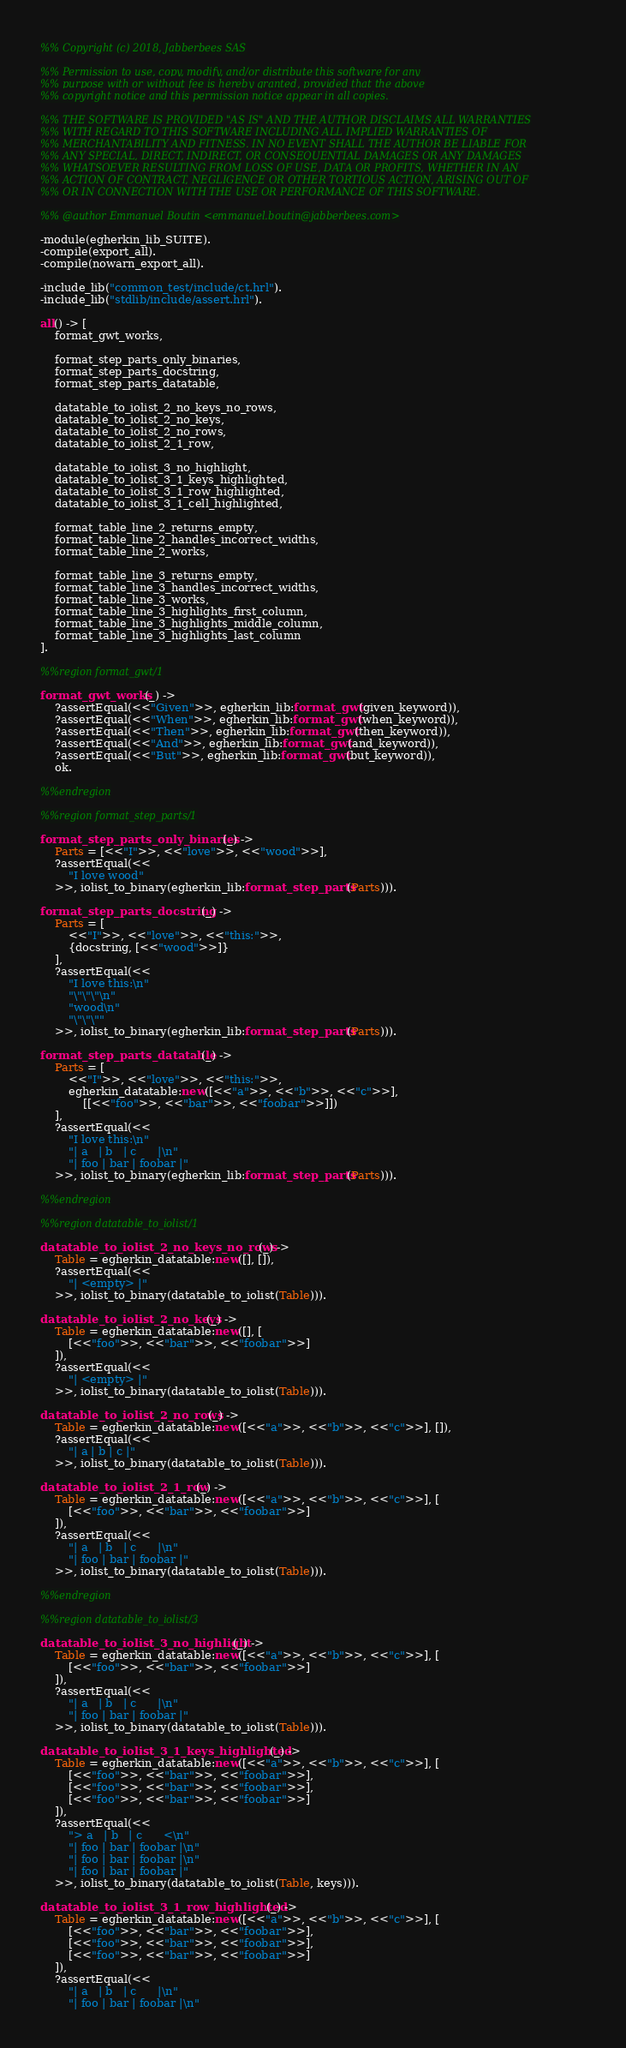Convert code to text. <code><loc_0><loc_0><loc_500><loc_500><_Erlang_>%% Copyright (c) 2018, Jabberbees SAS

%% Permission to use, copy, modify, and/or distribute this software for any
%% purpose with or without fee is hereby granted, provided that the above
%% copyright notice and this permission notice appear in all copies.

%% THE SOFTWARE IS PROVIDED "AS IS" AND THE AUTHOR DISCLAIMS ALL WARRANTIES
%% WITH REGARD TO THIS SOFTWARE INCLUDING ALL IMPLIED WARRANTIES OF
%% MERCHANTABILITY AND FITNESS. IN NO EVENT SHALL THE AUTHOR BE LIABLE FOR
%% ANY SPECIAL, DIRECT, INDIRECT, OR CONSEQUENTIAL DAMAGES OR ANY DAMAGES
%% WHATSOEVER RESULTING FROM LOSS OF USE, DATA OR PROFITS, WHETHER IN AN
%% ACTION OF CONTRACT, NEGLIGENCE OR OTHER TORTIOUS ACTION, ARISING OUT OF
%% OR IN CONNECTION WITH THE USE OR PERFORMANCE OF THIS SOFTWARE.

%% @author Emmanuel Boutin <emmanuel.boutin@jabberbees.com>

-module(egherkin_lib_SUITE).
-compile(export_all).
-compile(nowarn_export_all).

-include_lib("common_test/include/ct.hrl").
-include_lib("stdlib/include/assert.hrl").

all() -> [
    format_gwt_works,

    format_step_parts_only_binaries,
    format_step_parts_docstring,
    format_step_parts_datatable,

    datatable_to_iolist_2_no_keys_no_rows,
    datatable_to_iolist_2_no_keys,
    datatable_to_iolist_2_no_rows,
    datatable_to_iolist_2_1_row,

    datatable_to_iolist_3_no_highlight,
    datatable_to_iolist_3_1_keys_highlighted,
    datatable_to_iolist_3_1_row_highlighted,
    datatable_to_iolist_3_1_cell_highlighted,

    format_table_line_2_returns_empty,
    format_table_line_2_handles_incorrect_widths,
    format_table_line_2_works,

    format_table_line_3_returns_empty,
    format_table_line_3_handles_incorrect_widths,
    format_table_line_3_works,
    format_table_line_3_highlights_first_column,
    format_table_line_3_highlights_middle_column,
    format_table_line_3_highlights_last_column
].

%%region format_gwt/1

format_gwt_works(_) ->
	?assertEqual(<<"Given">>, egherkin_lib:format_gwt(given_keyword)),
	?assertEqual(<<"When">>, egherkin_lib:format_gwt(when_keyword)),
	?assertEqual(<<"Then">>, egherkin_lib:format_gwt(then_keyword)),
	?assertEqual(<<"And">>, egherkin_lib:format_gwt(and_keyword)),
	?assertEqual(<<"But">>, egherkin_lib:format_gwt(but_keyword)),
    ok.

%%endregion

%%region format_step_parts/1

format_step_parts_only_binaries(_) ->
    Parts = [<<"I">>, <<"love">>, <<"wood">>],
	?assertEqual(<<
        "I love wood"
    >>, iolist_to_binary(egherkin_lib:format_step_parts(Parts))).

format_step_parts_docstring(_) ->
    Parts = [
        <<"I">>, <<"love">>, <<"this:">>,
        {docstring, [<<"wood">>]}
    ],
	?assertEqual(<<
        "I love this:\n"
        "\"\"\"\n"
        "wood\n"
        "\"\"\""
    >>, iolist_to_binary(egherkin_lib:format_step_parts(Parts))).

format_step_parts_datatable(_) ->
    Parts = [
        <<"I">>, <<"love">>, <<"this:">>,
        egherkin_datatable:new([<<"a">>, <<"b">>, <<"c">>],
            [[<<"foo">>, <<"bar">>, <<"foobar">>]])
    ],
	?assertEqual(<<
        "I love this:\n"
        "| a   | b   | c      |\n"
        "| foo | bar | foobar |"
    >>, iolist_to_binary(egherkin_lib:format_step_parts(Parts))).

%%endregion

%%region datatable_to_iolist/1

datatable_to_iolist_2_no_keys_no_rows(_) ->
    Table = egherkin_datatable:new([], []),
	?assertEqual(<<
        "| <empty> |"
    >>, iolist_to_binary(datatable_to_iolist(Table))).

datatable_to_iolist_2_no_keys(_) ->
    Table = egherkin_datatable:new([], [
        [<<"foo">>, <<"bar">>, <<"foobar">>]
    ]),
	?assertEqual(<<
        "| <empty> |"
    >>, iolist_to_binary(datatable_to_iolist(Table))).

datatable_to_iolist_2_no_rows(_) ->
    Table = egherkin_datatable:new([<<"a">>, <<"b">>, <<"c">>], []),
	?assertEqual(<<
        "| a | b | c |"
    >>, iolist_to_binary(datatable_to_iolist(Table))).

datatable_to_iolist_2_1_row(_) ->
    Table = egherkin_datatable:new([<<"a">>, <<"b">>, <<"c">>], [
        [<<"foo">>, <<"bar">>, <<"foobar">>]
    ]),
	?assertEqual(<<
        "| a   | b   | c      |\n"
        "| foo | bar | foobar |"
    >>, iolist_to_binary(datatable_to_iolist(Table))).

%%endregion

%%region datatable_to_iolist/3

datatable_to_iolist_3_no_highlight(_) ->
    Table = egherkin_datatable:new([<<"a">>, <<"b">>, <<"c">>], [
        [<<"foo">>, <<"bar">>, <<"foobar">>]
    ]),
	?assertEqual(<<
        "| a   | b   | c      |\n"
        "| foo | bar | foobar |"
    >>, iolist_to_binary(datatable_to_iolist(Table))).

datatable_to_iolist_3_1_keys_highlighted(_) ->
    Table = egherkin_datatable:new([<<"a">>, <<"b">>, <<"c">>], [
        [<<"foo">>, <<"bar">>, <<"foobar">>],
        [<<"foo">>, <<"bar">>, <<"foobar">>],
        [<<"foo">>, <<"bar">>, <<"foobar">>]
    ]),
	?assertEqual(<<
        "> a   | b   | c      <\n"
        "| foo | bar | foobar |\n"
        "| foo | bar | foobar |\n"
        "| foo | bar | foobar |"
    >>, iolist_to_binary(datatable_to_iolist(Table, keys))).

datatable_to_iolist_3_1_row_highlighted(_) ->
    Table = egherkin_datatable:new([<<"a">>, <<"b">>, <<"c">>], [
        [<<"foo">>, <<"bar">>, <<"foobar">>],
        [<<"foo">>, <<"bar">>, <<"foobar">>],
        [<<"foo">>, <<"bar">>, <<"foobar">>]
    ]),
	?assertEqual(<<
        "| a   | b   | c      |\n"
        "| foo | bar | foobar |\n"</code> 